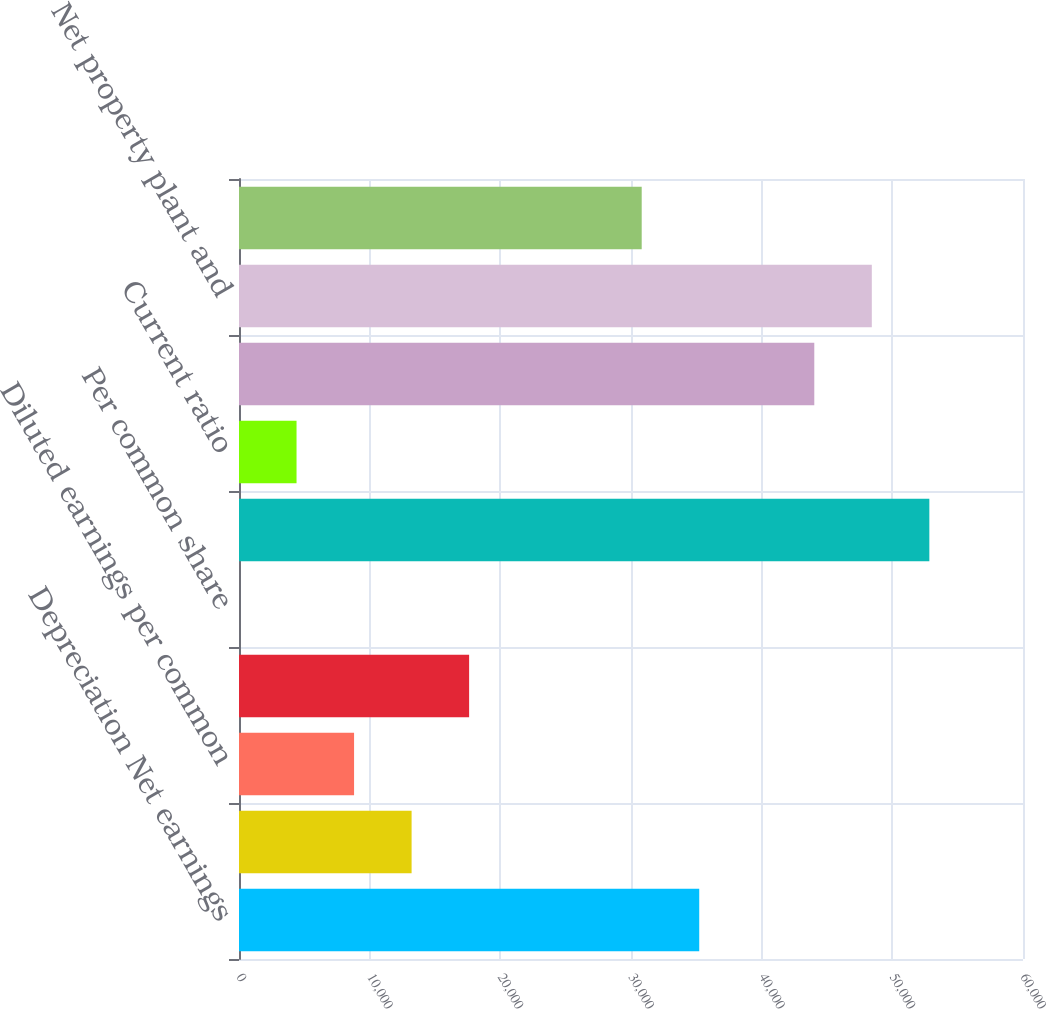Convert chart. <chart><loc_0><loc_0><loc_500><loc_500><bar_chart><fcel>Depreciation Net earnings<fcel>Basic earnings per common<fcel>Diluted earnings per common<fcel>Cash dividends<fcel>Per common share<fcel>Working capital<fcel>Current ratio<fcel>Inventories<fcel>Net property plant and<fcel>Gross additions to property<nl><fcel>35221.8<fcel>13208.8<fcel>8806.16<fcel>17611.4<fcel>0.96<fcel>52832.2<fcel>4403.56<fcel>44027<fcel>48429.6<fcel>30819.2<nl></chart> 